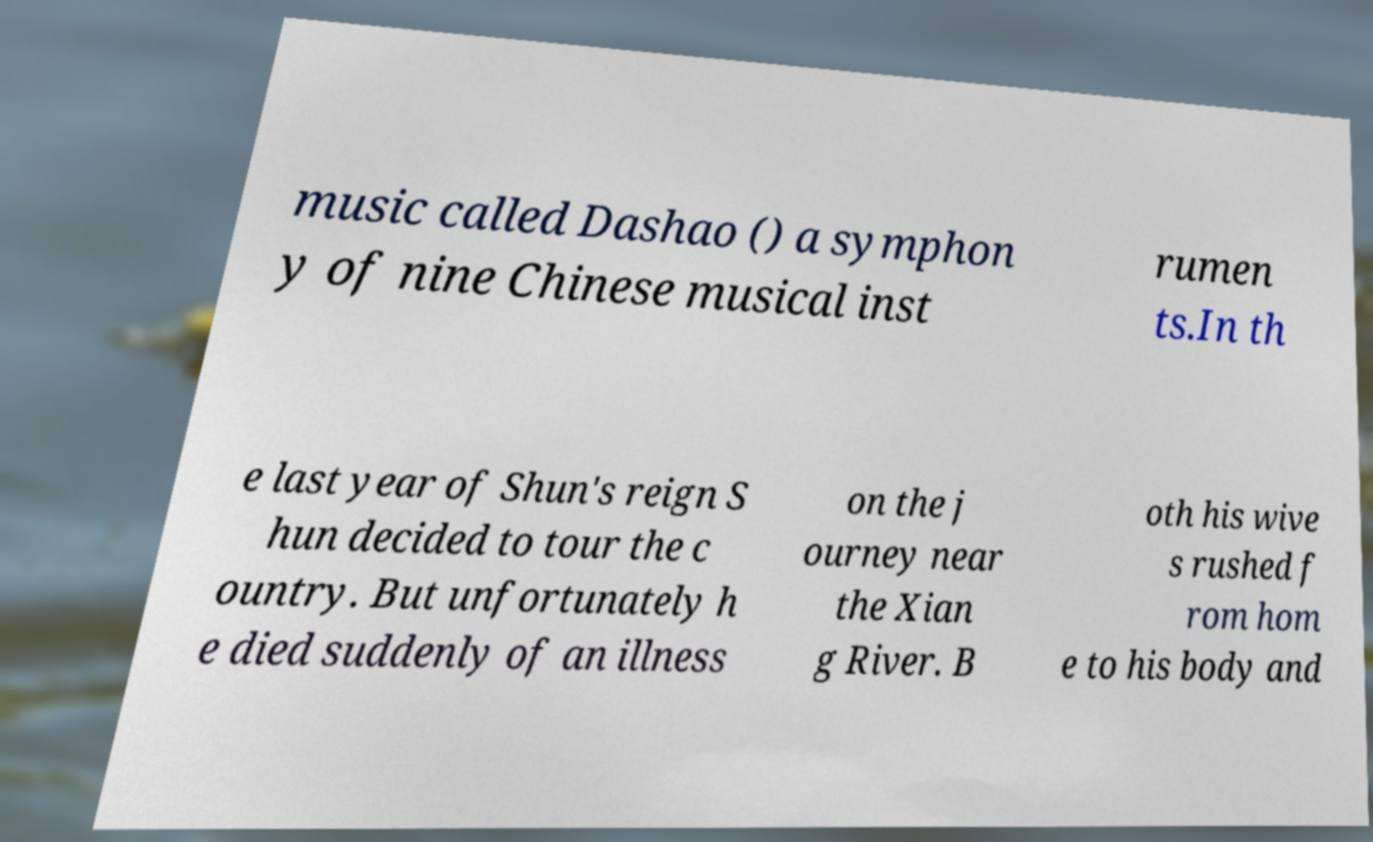Could you extract and type out the text from this image? music called Dashao () a symphon y of nine Chinese musical inst rumen ts.In th e last year of Shun's reign S hun decided to tour the c ountry. But unfortunately h e died suddenly of an illness on the j ourney near the Xian g River. B oth his wive s rushed f rom hom e to his body and 